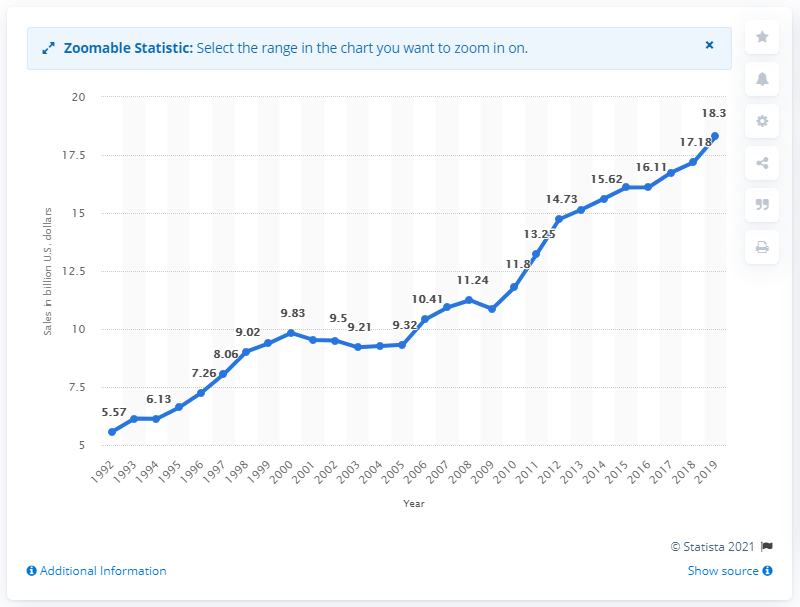Point out several critical features in this image. In 2019, the value of U.S. used merchandise store sales was 18.3 billion dollars. 